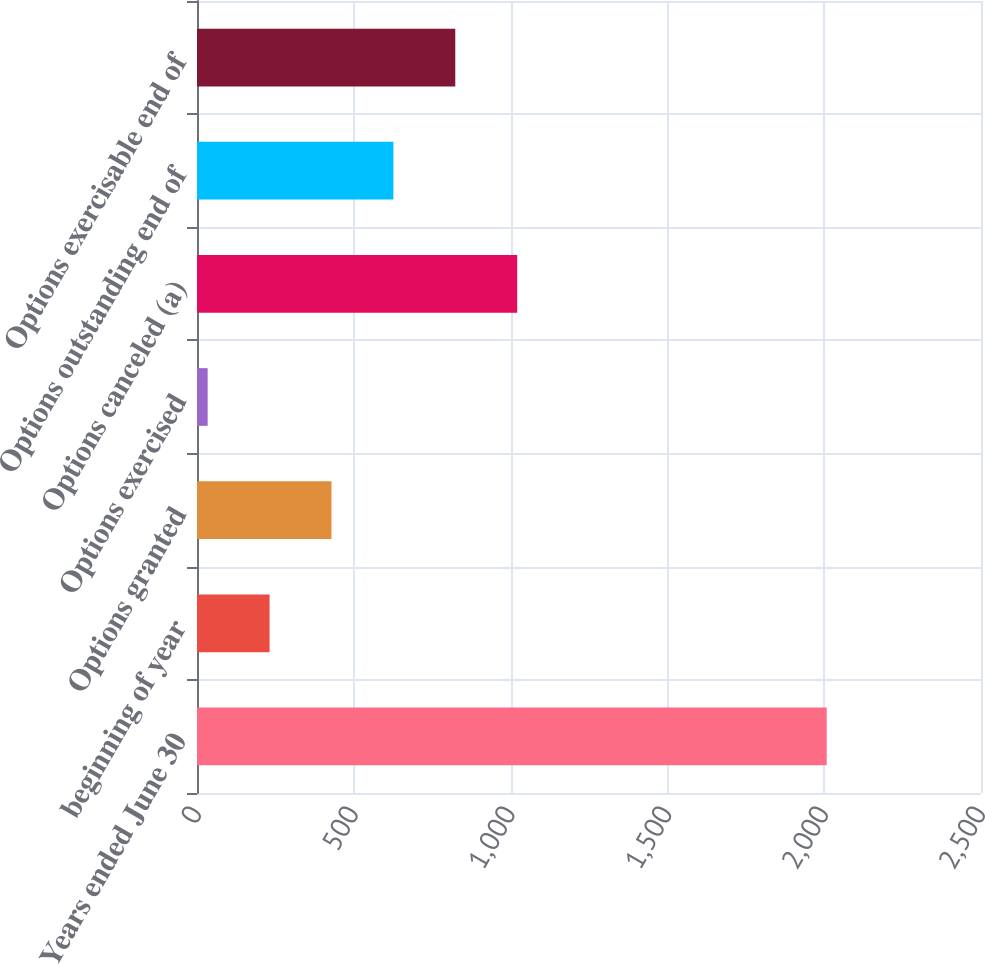<chart> <loc_0><loc_0><loc_500><loc_500><bar_chart><fcel>Years ended June 30<fcel>beginning of year<fcel>Options granted<fcel>Options exercised<fcel>Options canceled (a)<fcel>Options outstanding end of<fcel>Options exercisable end of<nl><fcel>2008<fcel>231.4<fcel>428.8<fcel>34<fcel>1021<fcel>626.2<fcel>823.6<nl></chart> 